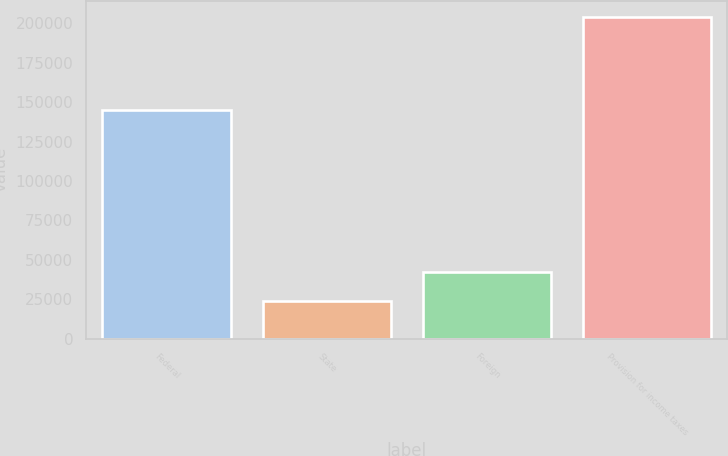Convert chart to OTSL. <chart><loc_0><loc_0><loc_500><loc_500><bar_chart><fcel>Federal<fcel>State<fcel>Foreign<fcel>Provision for income taxes<nl><fcel>144924<fcel>24052<fcel>42073.2<fcel>204264<nl></chart> 